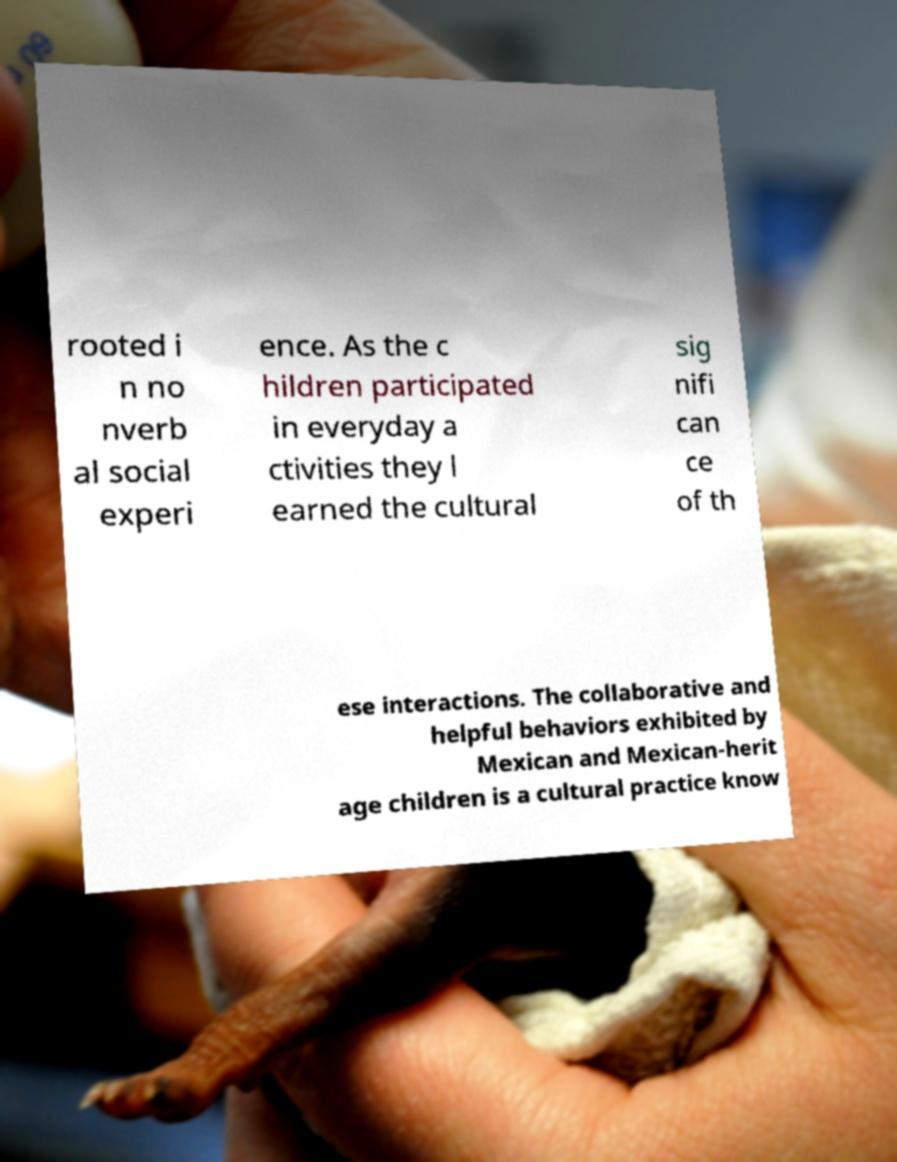Could you assist in decoding the text presented in this image and type it out clearly? rooted i n no nverb al social experi ence. As the c hildren participated in everyday a ctivities they l earned the cultural sig nifi can ce of th ese interactions. The collaborative and helpful behaviors exhibited by Mexican and Mexican-herit age children is a cultural practice know 